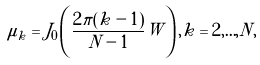Convert formula to latex. <formula><loc_0><loc_0><loc_500><loc_500>\mu _ { k } = J _ { 0 } \left ( \frac { 2 \pi ( k - 1 ) } { N - 1 } W \right ) , k = 2 , { \dots } , N ,</formula> 